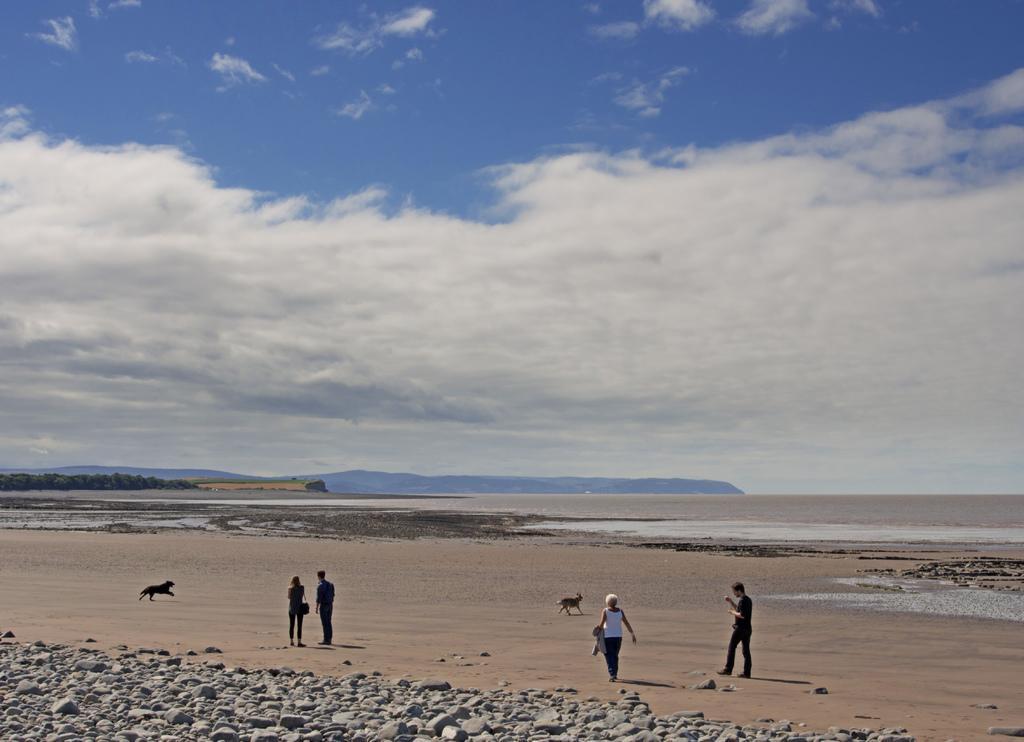In one or two sentences, can you explain what this image depicts? In this image I can see few people and two animals standing on the sand. These people are wearing the different color dresses. To the side I can see the stones. In the background I can see many trees, clouds and the sky. 